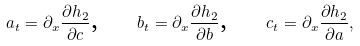<formula> <loc_0><loc_0><loc_500><loc_500>a _ { t } = \partial _ { x } \frac { \partial h _ { 2 } } { \partial c } \text {, \quad } b _ { t } = \partial _ { x } \frac { \partial h _ { 2 } } { \partial b } \text {, \quad } c _ { t } = \partial _ { x } \frac { \partial h _ { 2 } } { \partial a } ,</formula> 